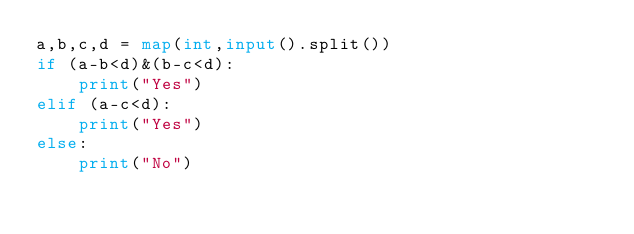Convert code to text. <code><loc_0><loc_0><loc_500><loc_500><_Python_>a,b,c,d = map(int,input().split())
if (a-b<d)&(b-c<d):
    print("Yes")
elif (a-c<d):
    print("Yes")
else:
    print("No")</code> 